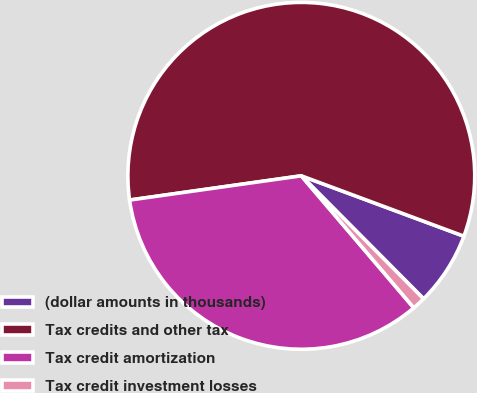Convert chart to OTSL. <chart><loc_0><loc_0><loc_500><loc_500><pie_chart><fcel>(dollar amounts in thousands)<fcel>Tax credits and other tax<fcel>Tax credit amortization<fcel>Tax credit investment losses<nl><fcel>6.89%<fcel>57.89%<fcel>34.0%<fcel>1.22%<nl></chart> 